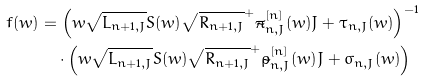<formula> <loc_0><loc_0><loc_500><loc_500>f ( w ) & = \left ( w \sqrt { L _ { n + 1 , J } } S ( w ) \sqrt { R _ { n + 1 , J } } ^ { + } \tilde { \pi } _ { n , J } ^ { [ n ] } ( w ) J + \tau _ { n , J } ( w ) \right ) ^ { - 1 } \\ & \quad \cdot \left ( w \sqrt { L _ { n + 1 , J } } S ( w ) \sqrt { R _ { n + 1 , J } } ^ { + } \tilde { \rho } _ { n , J } ^ { [ n ] } ( w ) J + \sigma _ { n , J } ( w ) \right )</formula> 